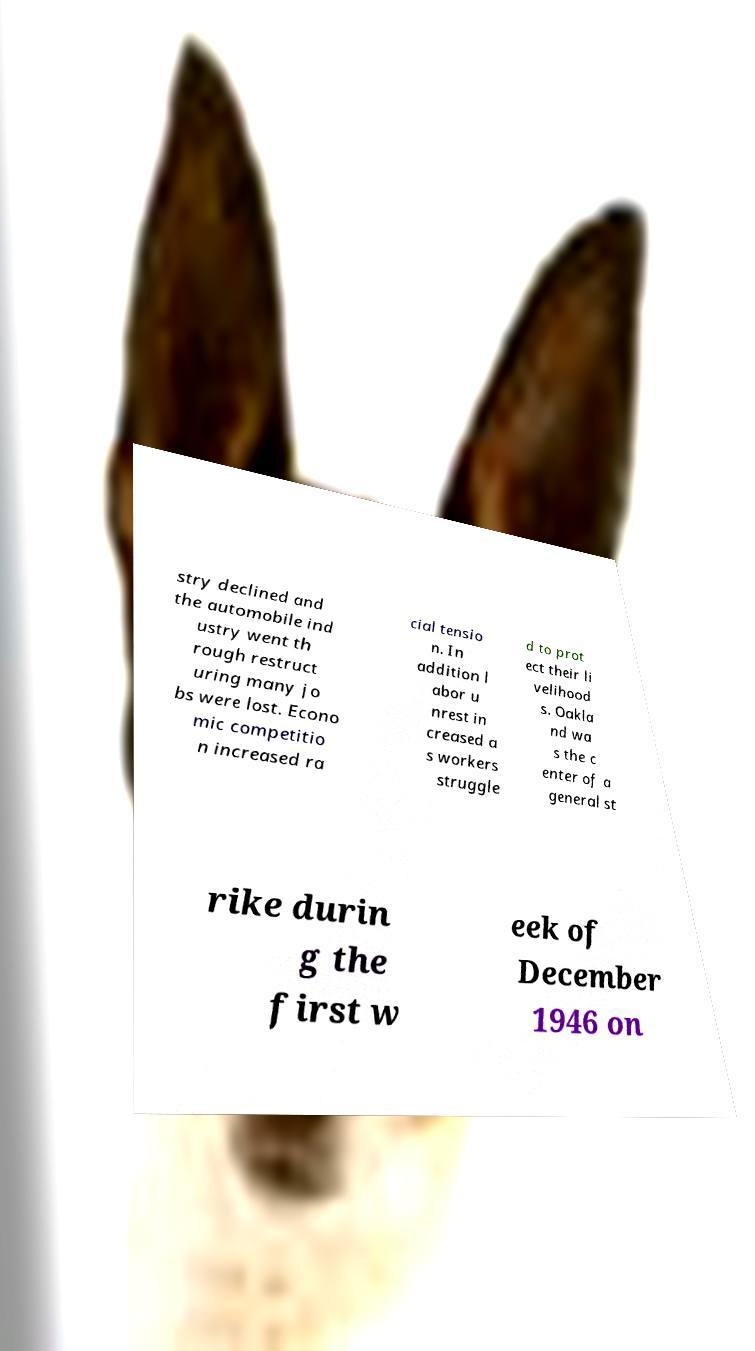Please identify and transcribe the text found in this image. stry declined and the automobile ind ustry went th rough restruct uring many jo bs were lost. Econo mic competitio n increased ra cial tensio n. In addition l abor u nrest in creased a s workers struggle d to prot ect their li velihood s. Oakla nd wa s the c enter of a general st rike durin g the first w eek of December 1946 on 